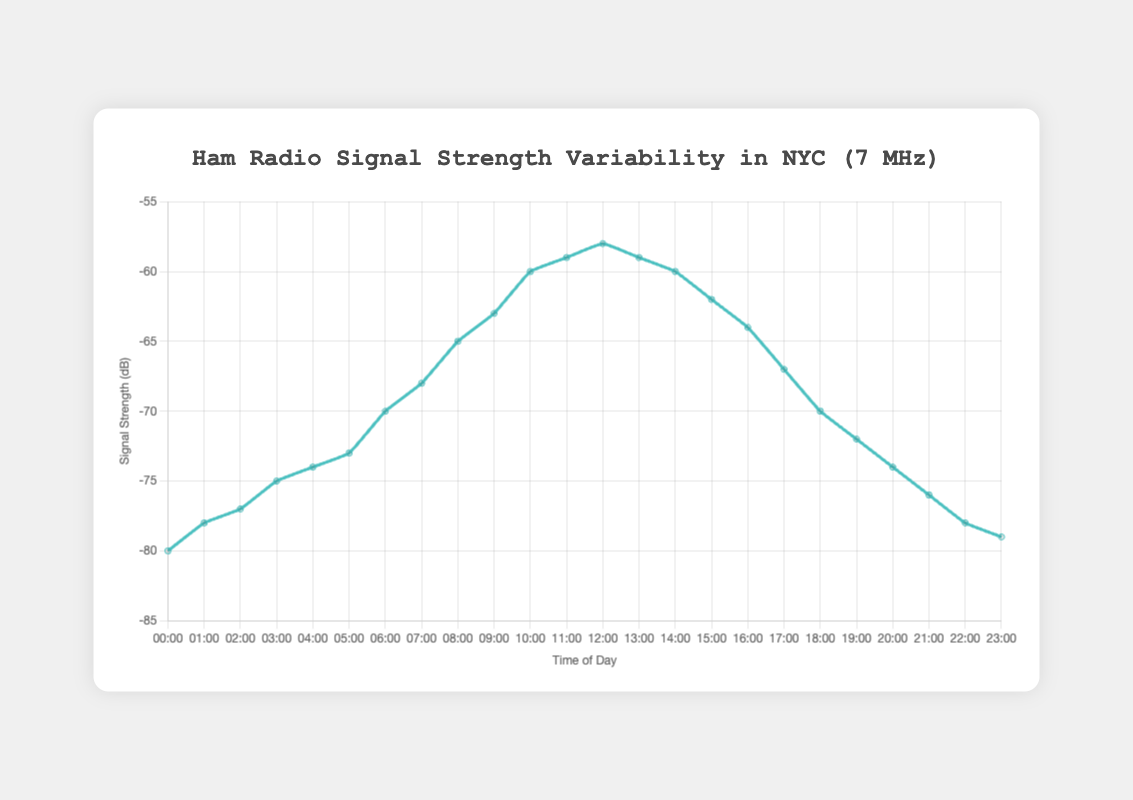What is the signal strength at 10:00? Observing the plot, the signal strength at 10:00 is visibly marked.
Answer: -60 dB Between which two hours is the largest increase in signal strength? Analyzing the plot, the largest increase is between 06:00 and 07:00 where the signal strength changes from -70 dB to -68 dB.
Answer: Between 06:00 and 07:00 What is the average signal strength between 09:00 and 12:00? The signal strengths at 09:00, 10:00, 11:00, and 12:00 are -63, -60, -59, and -58 dB respectively. Calculating the average: \[( -63 + -60 + -59 + -58)/4 = -60 \]
Answer: -60 dB At what time of the day does the signal strength reach its peak? Peak signal strength is the highest point on the plot. The highest signal strength is at 12:00 with -58 dB.
Answer: 12:00 How does the signal strength at 22:00 compare to the signal strength at 06:00? Comparing the values, signal strength at 22:00 is -78 dB and at 06:00 it is -70 dB, indicating that the signal is weaker by 8 dB at 22:00.
Answer: Weaker by 8 dB at 22:00 What is the median signal strength over the entire day? The signal strengths sorted are: -80, -79, -78, -78, -77, -76, -75, -74, -74, -73, -72, -70, -68, -67, -65, -64, -63, -62, -60, -60, -59, -59, -58, making the median \((-67 + -65)/2 = -66 \)
Answer: -66 dB Which hour shows a signal strength equal to -74 dB? Observing the plot, -74 dB is found at both 04:00 and 20:00 hours.
Answer: 04:00 and 20:00 Is the signal strength at 15:00 greater or less than that at 17:00? By checking the plot, the signal strength at 15:00 is -62 dB while at 17:00 it is -67 dB. Therefore, it is greater at 15:00.
Answer: Greater at 15:00 Between which two hours is the signal strength the weakest? The weakest value observed on the plot is -80 dB at both 00:00 and 23:00.
Answer: Between 00:00 and 01:00 and 22:00 and 23:00 How does the signal strength change from 00:00 to 12:00? From 00:00 (-80 dB) to 12:00 (-58 dB), the signal strength regularly increases (becomes less negative), showing a consistent improvement.
Answer: Increases 